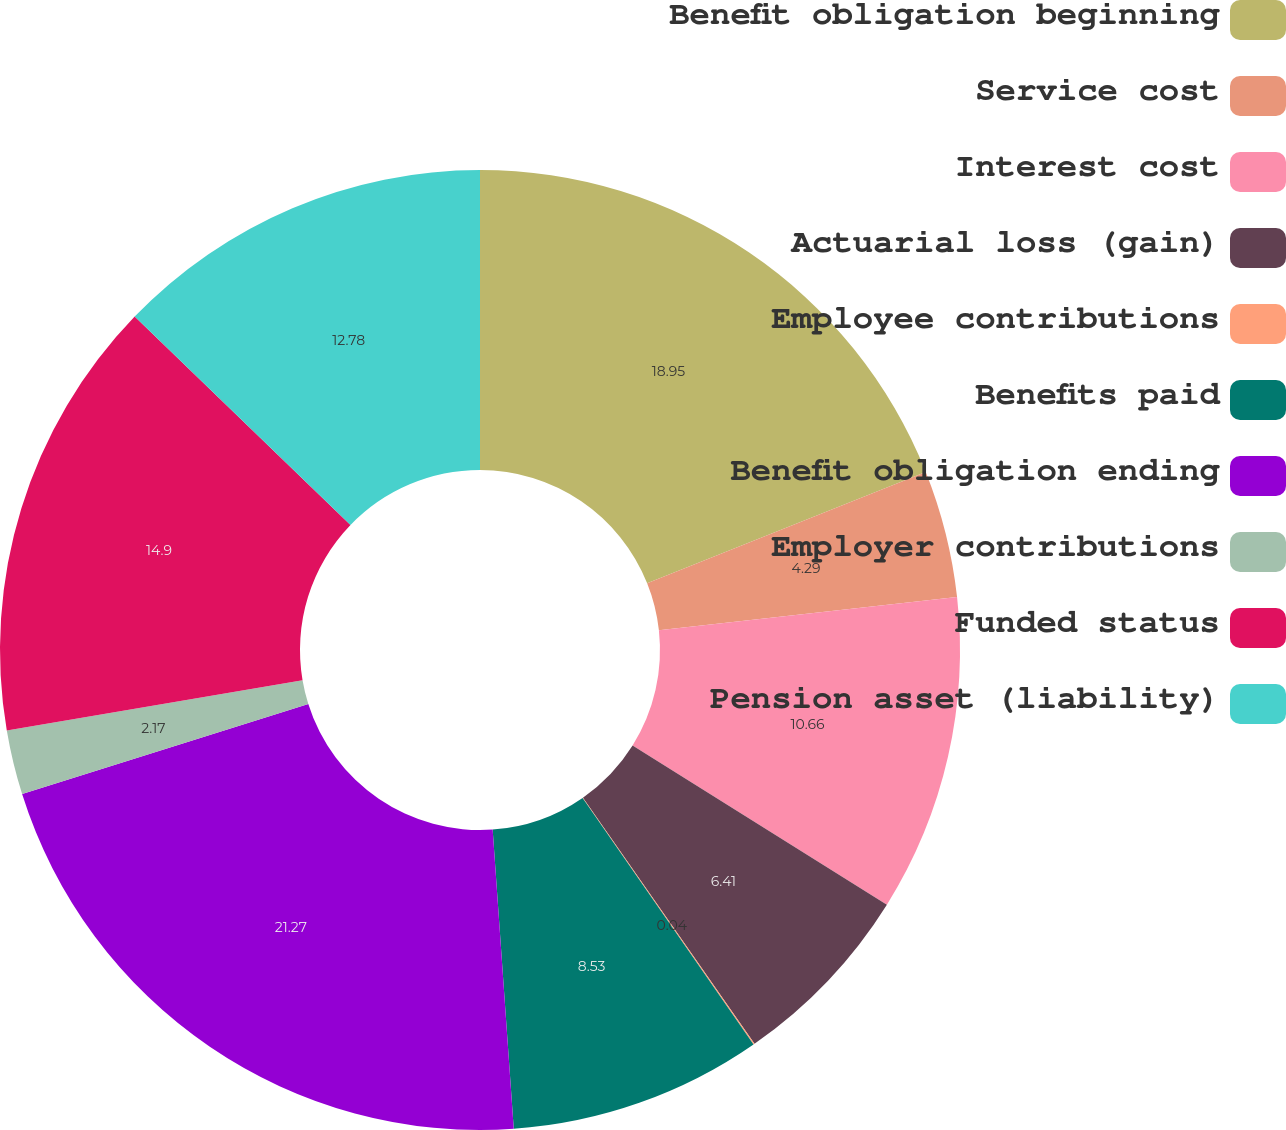Convert chart to OTSL. <chart><loc_0><loc_0><loc_500><loc_500><pie_chart><fcel>Benefit obligation beginning<fcel>Service cost<fcel>Interest cost<fcel>Actuarial loss (gain)<fcel>Employee contributions<fcel>Benefits paid<fcel>Benefit obligation ending<fcel>Employer contributions<fcel>Funded status<fcel>Pension asset (liability)<nl><fcel>18.95%<fcel>4.29%<fcel>10.66%<fcel>6.41%<fcel>0.04%<fcel>8.53%<fcel>21.27%<fcel>2.17%<fcel>14.9%<fcel>12.78%<nl></chart> 